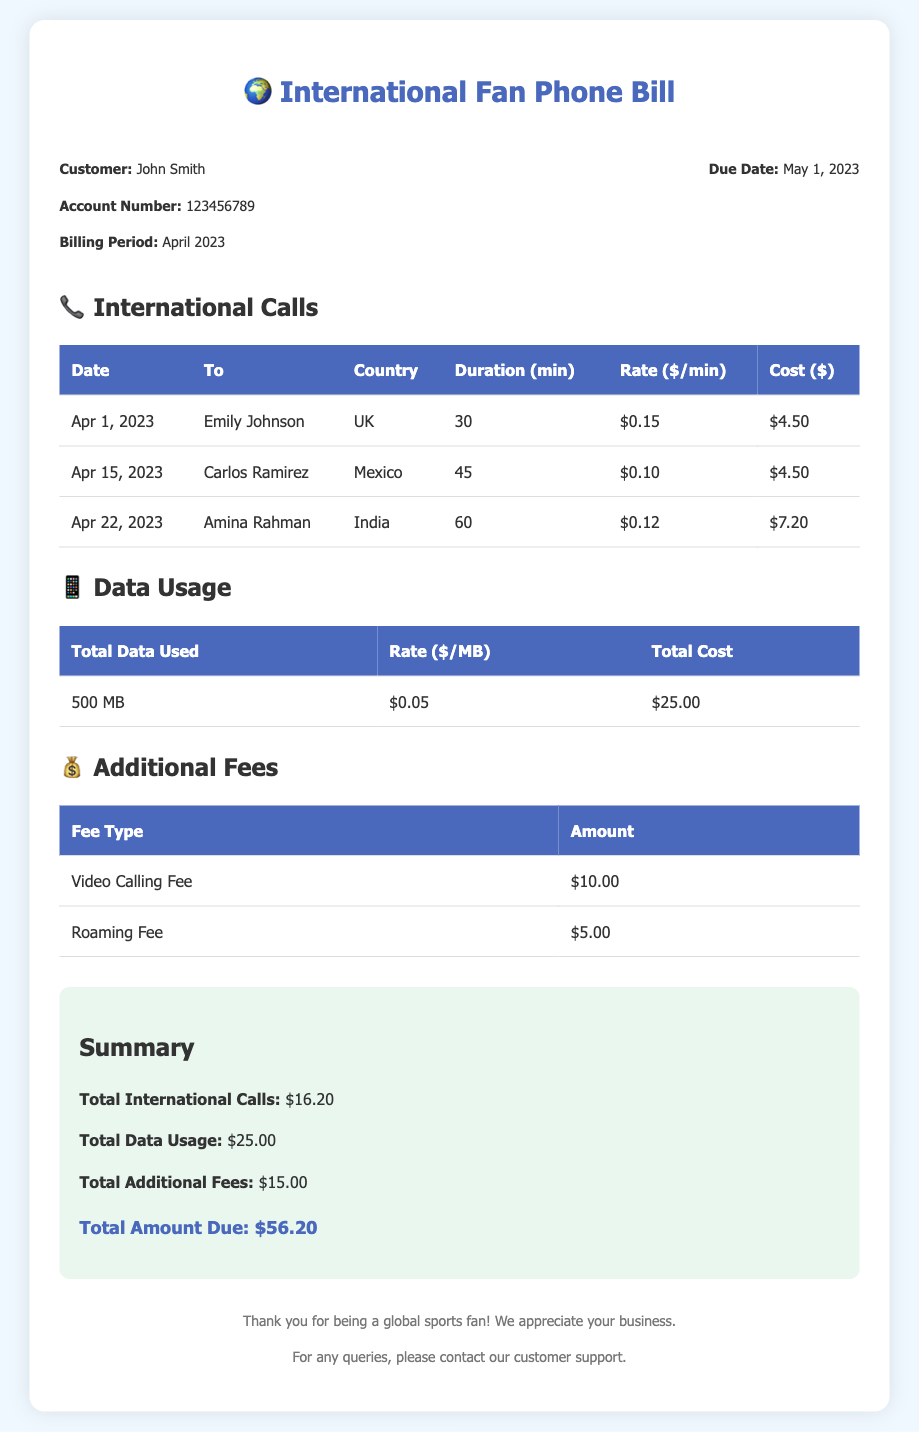What is the billing period? The billing period is specified in the document, detailing the duration for which the charges apply.
Answer: April 2023 Who is the customer? The document states the name of the person receiving the bill, which helps in identifying the account owner.
Answer: John Smith What is the cost of international calls? This cost is provided as a sum of individual call costs listed in the international calls section of the document.
Answer: $16.20 What is the total data used? The total data used is found in the data usage section, which quantifies the amount of data consumed.
Answer: 500 MB What is the video calling fee? The additional fee section includes specific charges related to the usage of video calling services.
Answer: $10.00 What is the total amount due? The total amount due is clearly mentioned as the final figure to be paid on account of all charges reflected in the bill.
Answer: $56.20 How many minutes were spent on the call to India? The international call details specify the duration of each call, particularly focusing on the call to India.
Answer: 60 What is the rate for calls to Mexico? The document lists the rate per minute specifically for calls to Mexico when detailing the calls made.
Answer: $0.10 What additional fee is incurred for roaming? This fee is listed under the additional fees section of the document, providing clarity on extra charges.
Answer: $5.00 